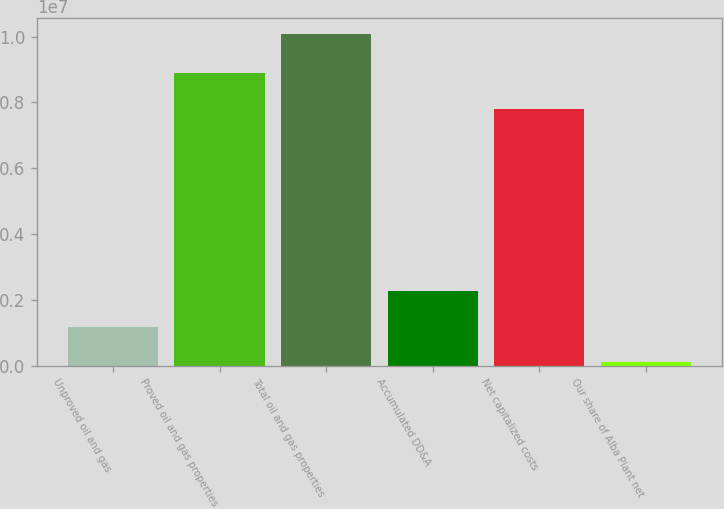Convert chart. <chart><loc_0><loc_0><loc_500><loc_500><bar_chart><fcel>Unproved oil and gas<fcel>Proved oil and gas properties<fcel>Total oil and gas properties<fcel>Accumulated DD&A<fcel>Net capitalized costs<fcel>Our share of Alba Plant net<nl><fcel>1.16471e+06<fcel>8.90316e+06<fcel>1.00679e+07<fcel>2.28079e+06<fcel>7.78708e+06<fcel>117212<nl></chart> 